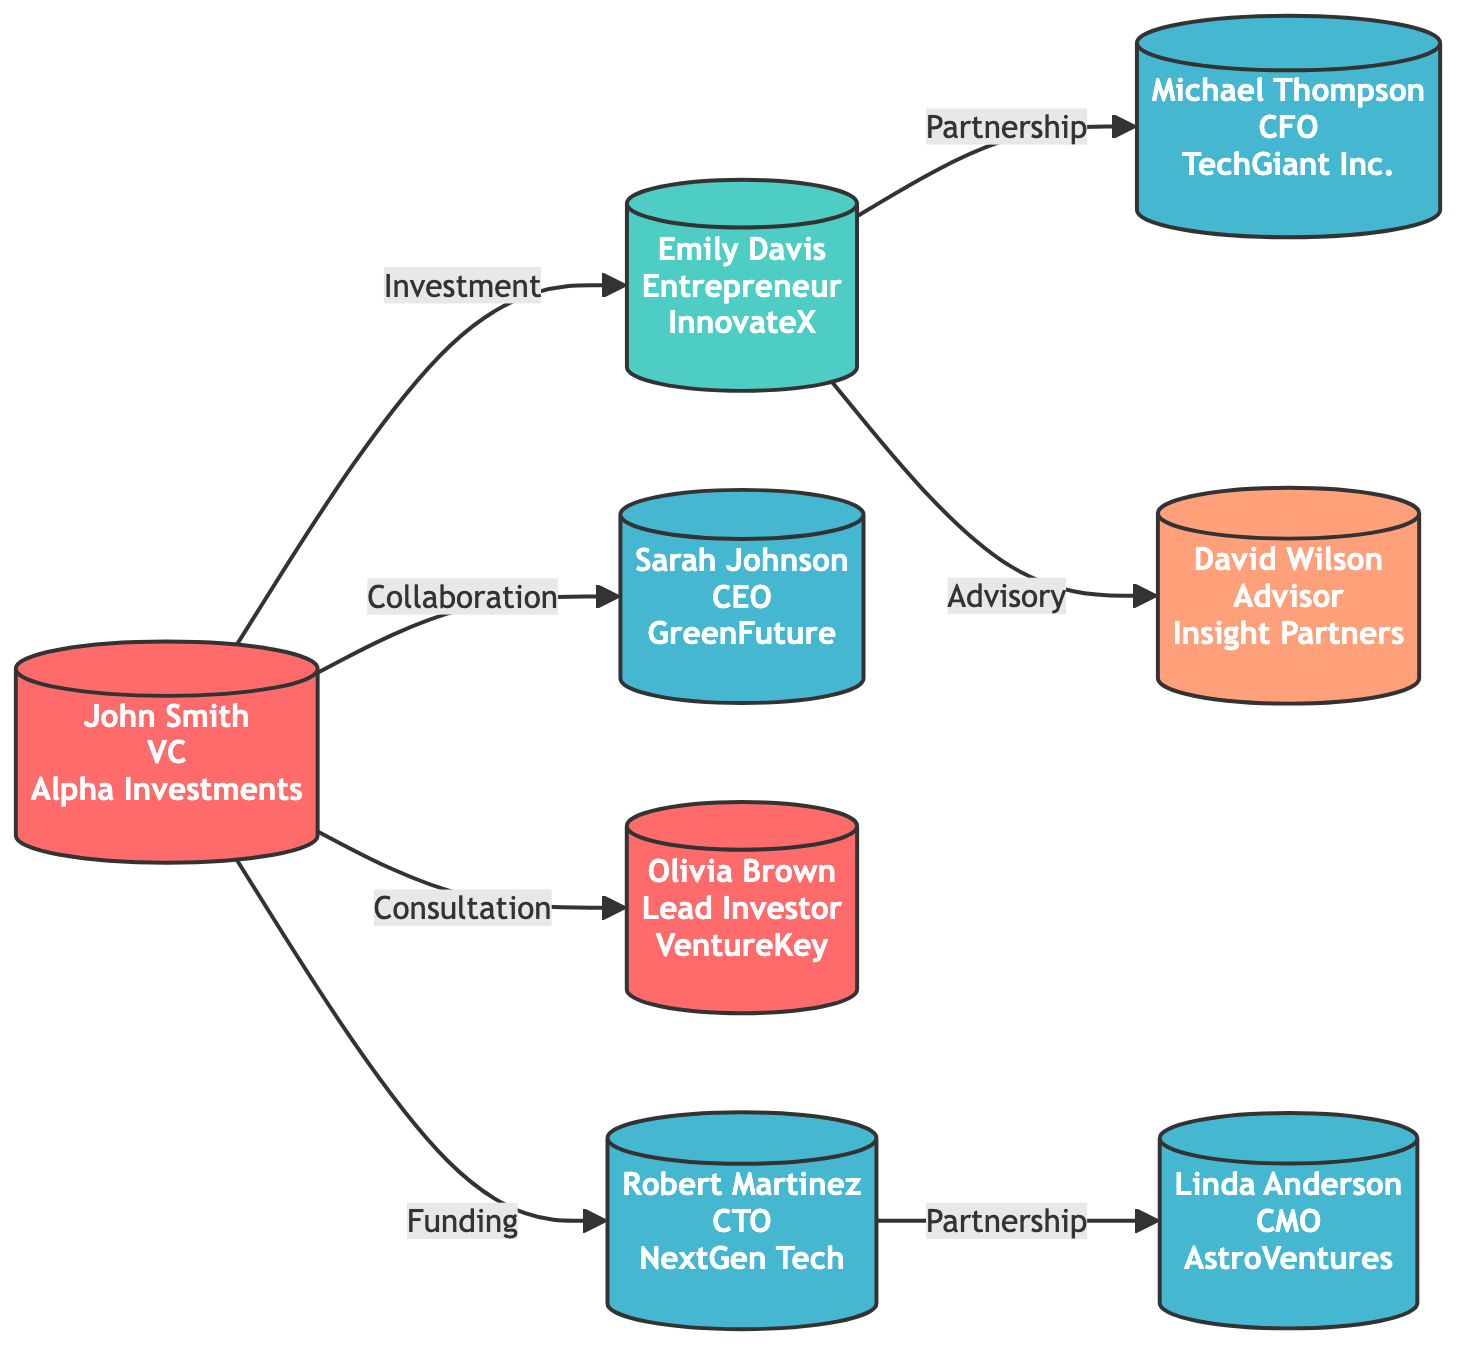What is the total number of nodes in the diagram? The diagram lists 8 individual entities, each representing a person or role in the network of industry influencers and partnerships. Therefore, counting these nodes gives us a total of 8.
Answer: 8 Who is the CEO in the diagram? The diagram indicates that Sarah Johnson holds the role of CEO, as denoted by her title and connection to GreenFuture Ventures within the node information.
Answer: Sarah Johnson Which individual is linked to both John Smith and David Wilson? In the diagram, Emily Davis is connected to John Smith through an investment relationship and also linked to David Wilson via an advisory connection, making her the individual linked to both.
Answer: Emily Davis What type of relationship exists between Robert Martinez and Linda Anderson? The diagram shows a partnership relationship between Robert Martinez and Linda Anderson, specifying their collaboration in technology development as indicated by the arrow and relationship label.
Answer: Partnership What role does Olivia Brown serve in her affiliation? The diagram identifies Olivia Brown as the Lead Investor at VentureKey Capital, indicating her financial position and responsibilities there.
Answer: Lead Investor How many different types of relationships are illustrated in the diagram? Analyzing the relationships, we see 6 distinct types of relationships represented: Investment, Partnership, Collaboration, Advisory, Consultation, and Funding. Counting these reveals there are 6 different types.
Answer: 6 Which node has the most outgoing connections? By examining the nodes, John Smith has the most outgoing connections, with five direct connections to other nodes representing his active involvement in investment, collaboration, and consultations.
Answer: John Smith What is the primary role of Michael Thompson? The diagram assigns Michael Thompson the role of CFO at TechGiant Inc., clearly stating his position within the company along with his connection to Emily Davis.
Answer: CFO 